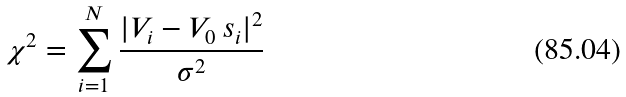Convert formula to latex. <formula><loc_0><loc_0><loc_500><loc_500>\chi ^ { 2 } = \sum _ { i = 1 } ^ { N } \frac { | V _ { i } - V _ { 0 } \, s _ { i } | ^ { 2 } } { \sigma ^ { 2 } }</formula> 